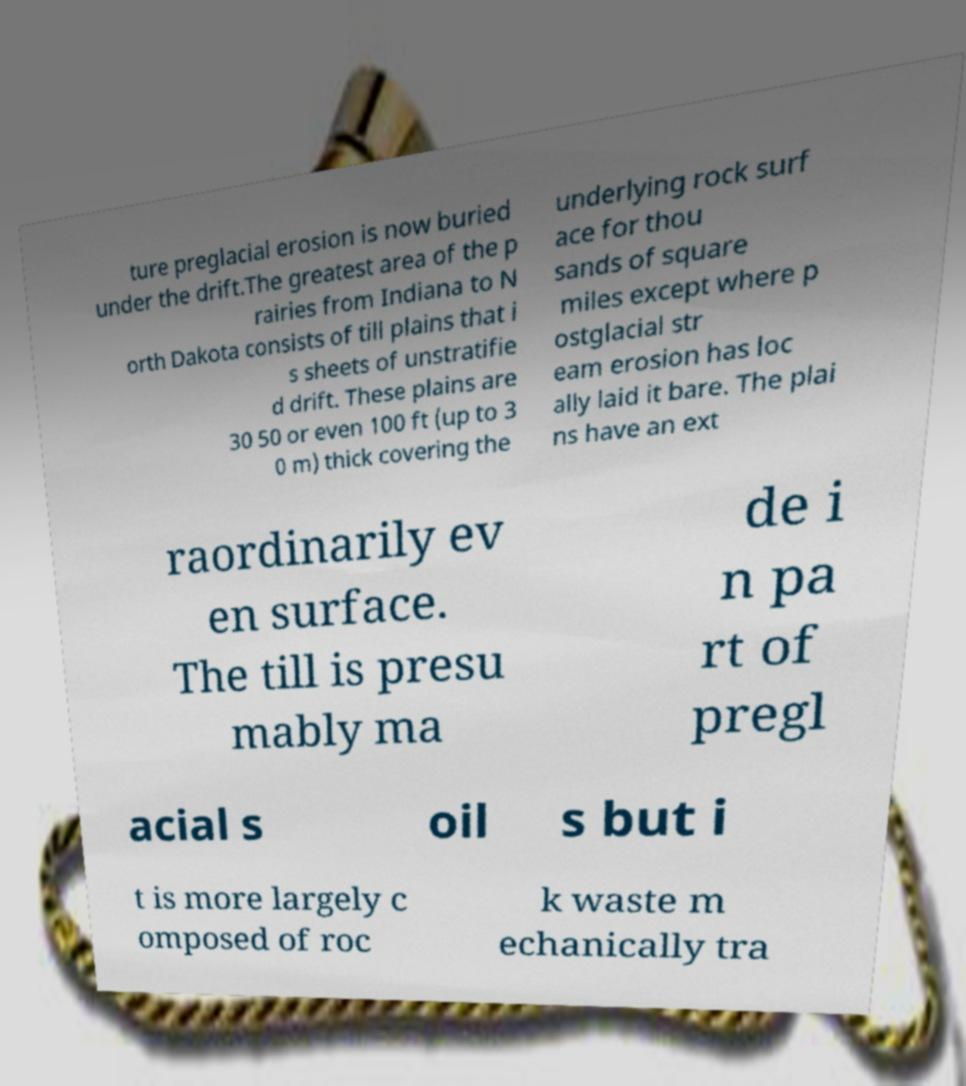Could you extract and type out the text from this image? ture preglacial erosion is now buried under the drift.The greatest area of the p rairies from Indiana to N orth Dakota consists of till plains that i s sheets of unstratifie d drift. These plains are 30 50 or even 100 ft (up to 3 0 m) thick covering the underlying rock surf ace for thou sands of square miles except where p ostglacial str eam erosion has loc ally laid it bare. The plai ns have an ext raordinarily ev en surface. The till is presu mably ma de i n pa rt of pregl acial s oil s but i t is more largely c omposed of roc k waste m echanically tra 